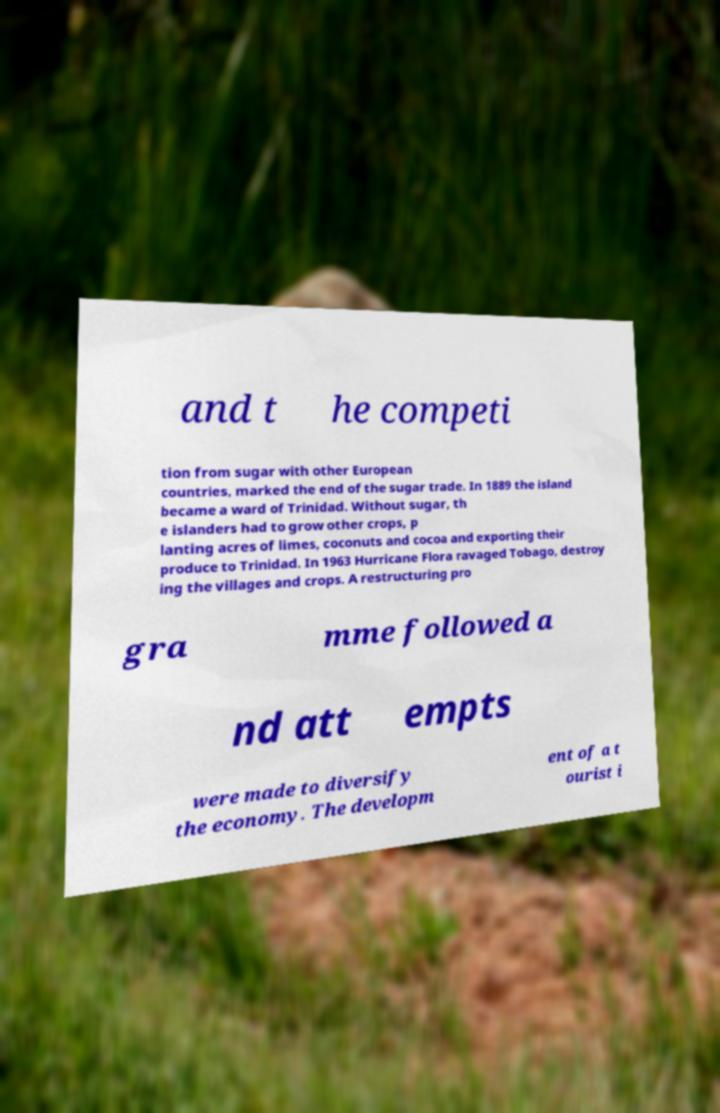I need the written content from this picture converted into text. Can you do that? and t he competi tion from sugar with other European countries, marked the end of the sugar trade. In 1889 the island became a ward of Trinidad. Without sugar, th e islanders had to grow other crops, p lanting acres of limes, coconuts and cocoa and exporting their produce to Trinidad. In 1963 Hurricane Flora ravaged Tobago, destroy ing the villages and crops. A restructuring pro gra mme followed a nd att empts were made to diversify the economy. The developm ent of a t ourist i 